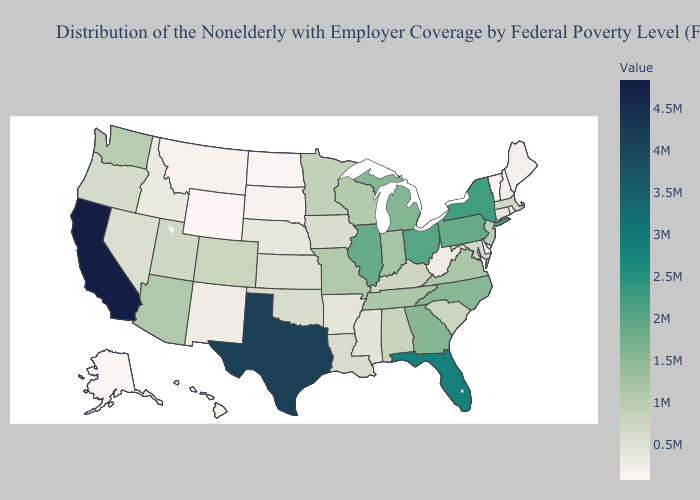Does Nevada have the lowest value in the USA?
Be succinct. No. Does Pennsylvania have the lowest value in the USA?
Be succinct. No. Does Iowa have a higher value than North Carolina?
Concise answer only. No. Does California have the highest value in the West?
Short answer required. Yes. Among the states that border Indiana , does Michigan have the highest value?
Be succinct. No. Does California have a higher value than Wisconsin?
Keep it brief. Yes. Does North Dakota have the lowest value in the MidWest?
Be succinct. Yes. Which states hav the highest value in the MidWest?
Answer briefly. Ohio. 